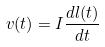Convert formula to latex. <formula><loc_0><loc_0><loc_500><loc_500>v ( t ) = I \frac { d l ( t ) } { d t }</formula> 